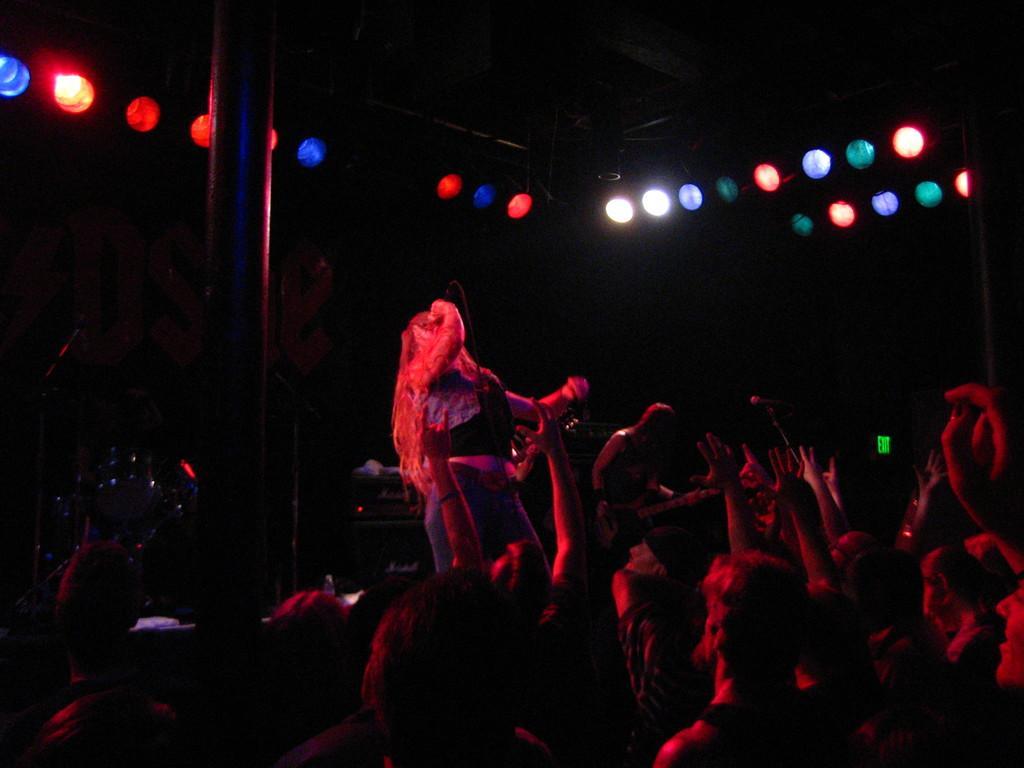How would you summarize this image in a sentence or two? This picture is clicked in a musical concert. The woman in the middle of the picture wearing a black and blue shirt is holding a microphone in her hands and she is singing the song on the microphone. At the bottom of the picture, we see people enjoying the music. Behind her, we see a pole and it is dark in the background. 